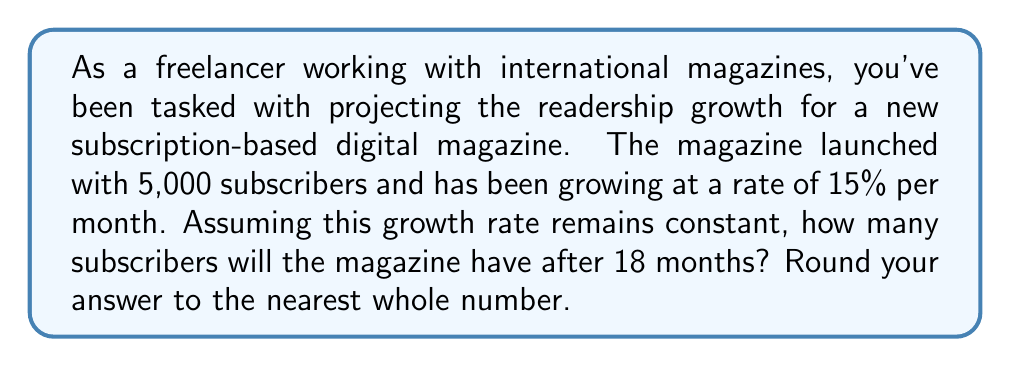Can you solve this math problem? To solve this problem, we'll use an exponential growth model. The general form of an exponential growth model is:

$$A(t) = A_0 \cdot (1 + r)^t$$

Where:
$A(t)$ is the amount after time $t$
$A_0$ is the initial amount
$r$ is the growth rate (as a decimal)
$t$ is the time period

Given:
$A_0 = 5,000$ (initial subscribers)
$r = 0.15$ (15% monthly growth rate)
$t = 18$ (months)

Let's plug these values into our exponential growth formula:

$$A(18) = 5,000 \cdot (1 + 0.15)^{18}$$

Now, let's calculate:

$$A(18) = 5,000 \cdot (1.15)^{18}$$
$$A(18) = 5,000 \cdot 13.0069...$$
$$A(18) = 65,034.71...$$

Rounding to the nearest whole number:

$$A(18) \approx 65,035$$

Therefore, after 18 months, the magazine will have approximately 65,035 subscribers.
Answer: 65,035 subscribers 